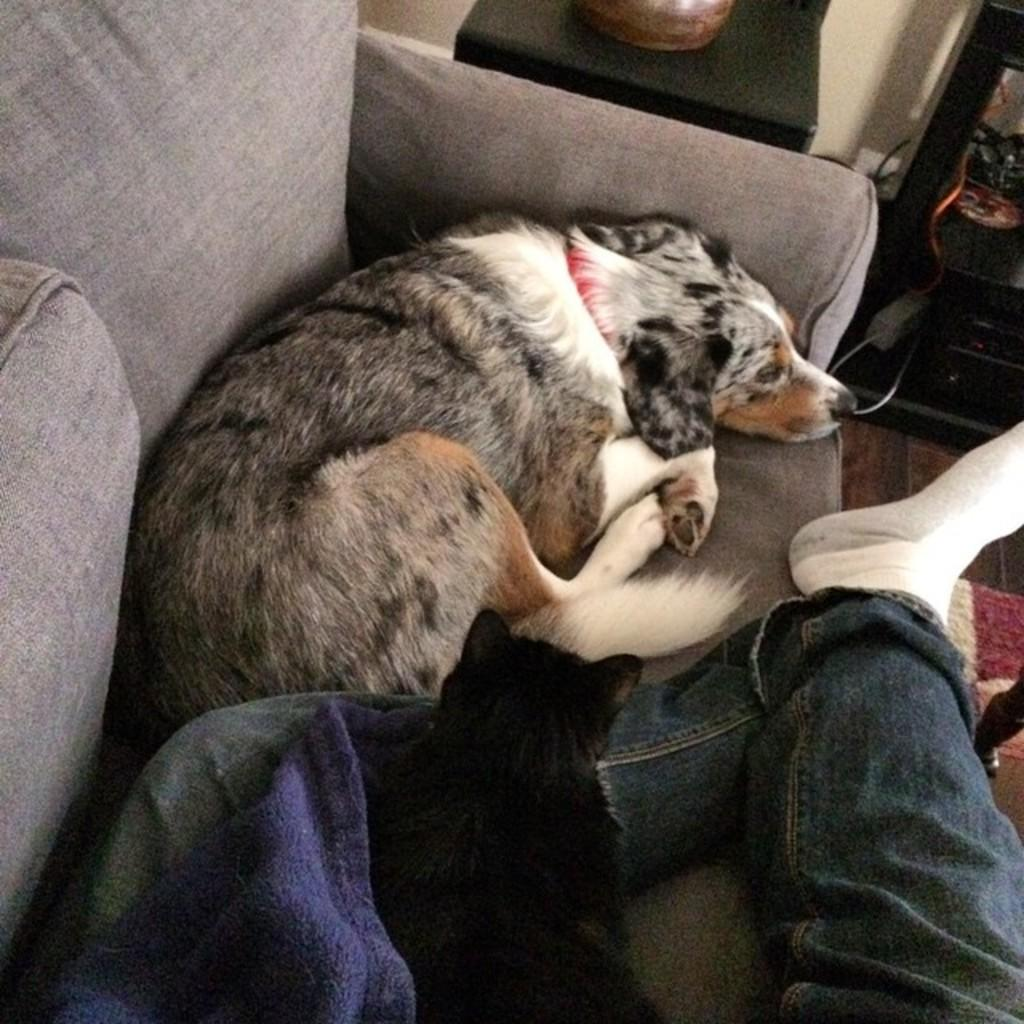What type of furniture is in the image? There is a sofa in the image. What animals are on the sofa? There is a cat and a dog laying on the sofa. Where is the cat positioned on the sofa? The cat is laying on the leg of a person. What is located beside the sofa? There is a table beside the sofa. What can be seen in the background of the image? There is a wall in the background of the image. What type of dirt can be seen on the floor in the image? There is no dirt visible on the floor in the image. What arithmetic problem is the cat solving on the sofa? The image does not show the cat solving any arithmetic problem. What type of eggnog is being served on the table beside the sofa? There is no eggnog present in the image. 